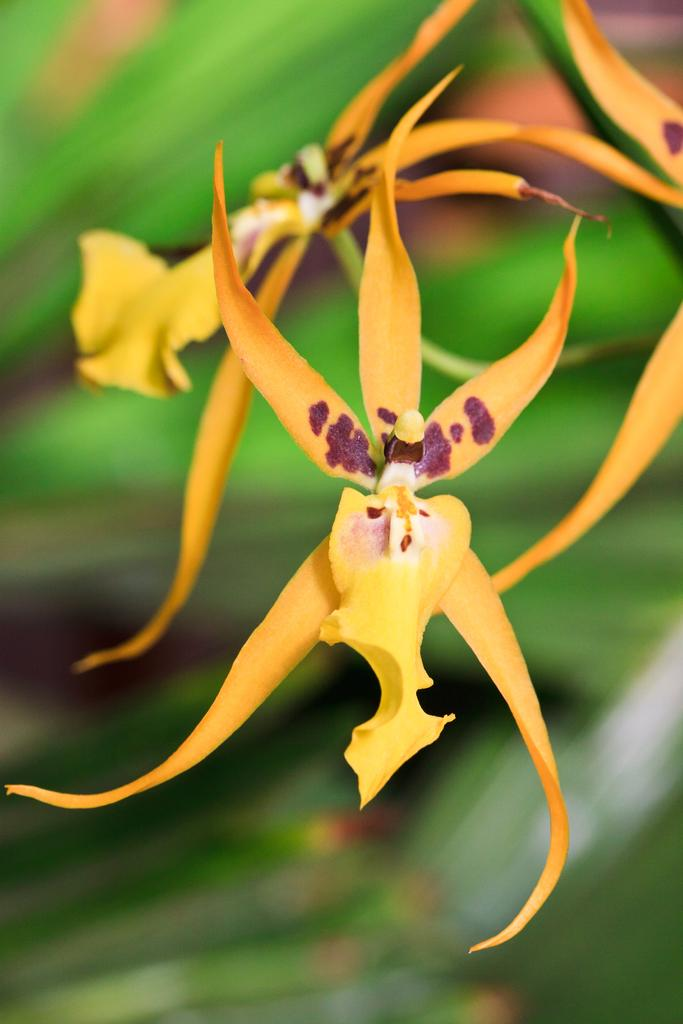What is the main subject of the image? The main subject of the image is a flower. Can you describe the color of the flower? The flower is in yellowish orange color. How many pigs are holding the flower in the image? There are no pigs present in the image, and therefore no pigs are holding the flower. 